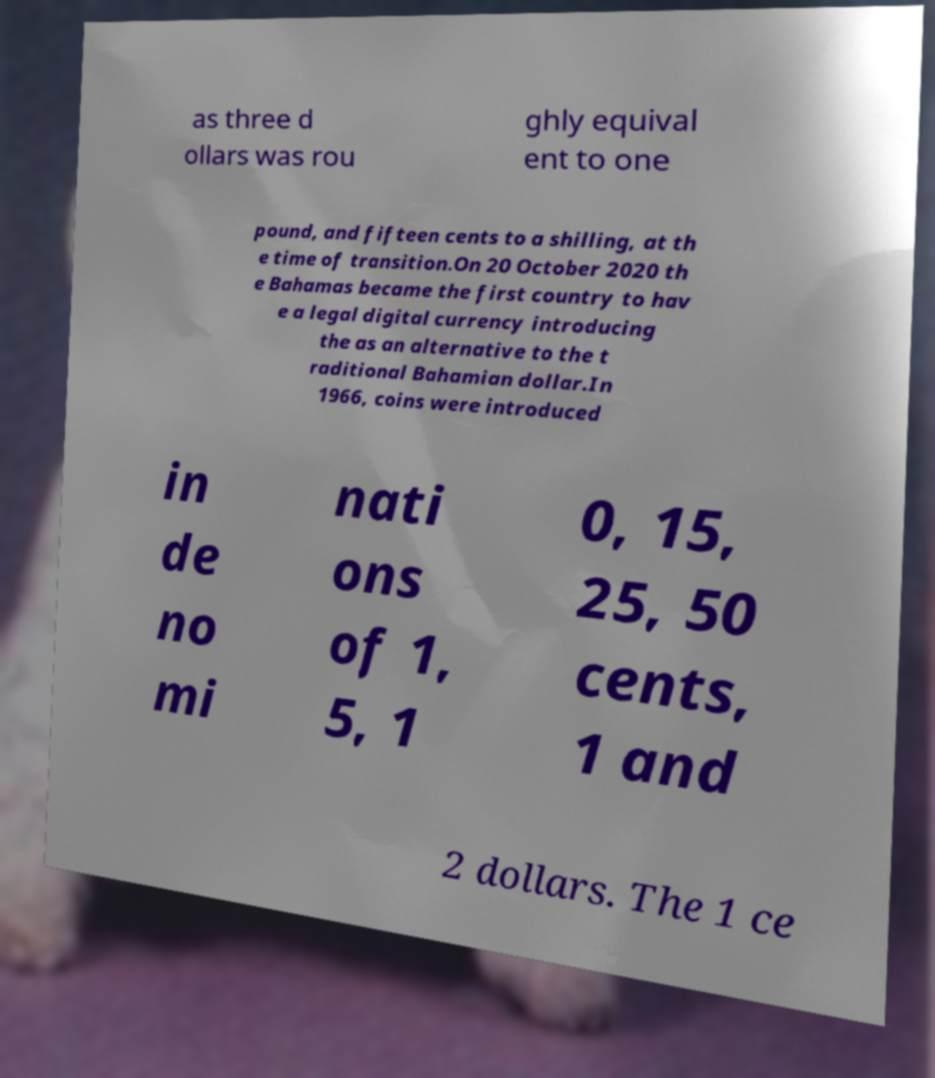I need the written content from this picture converted into text. Can you do that? as three d ollars was rou ghly equival ent to one pound, and fifteen cents to a shilling, at th e time of transition.On 20 October 2020 th e Bahamas became the first country to hav e a legal digital currency introducing the as an alternative to the t raditional Bahamian dollar.In 1966, coins were introduced in de no mi nati ons of 1, 5, 1 0, 15, 25, 50 cents, 1 and 2 dollars. The 1 ce 